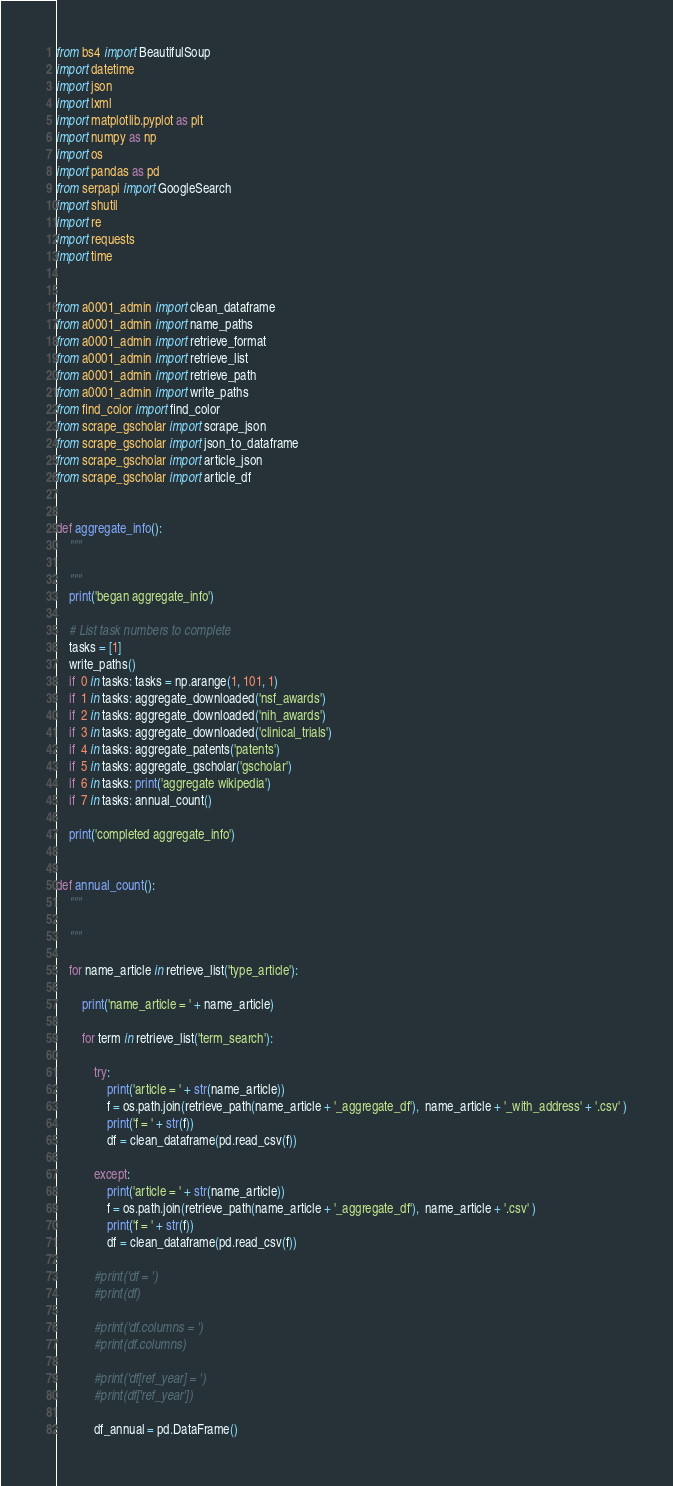Convert code to text. <code><loc_0><loc_0><loc_500><loc_500><_Python_>from bs4 import BeautifulSoup
import datetime
import json
import lxml
import matplotlib.pyplot as plt
import numpy as np
import os
import pandas as pd
from serpapi import GoogleSearch
import shutil
import re
import requests
import time


from a0001_admin import clean_dataframe
from a0001_admin import name_paths
from a0001_admin import retrieve_format
from a0001_admin import retrieve_list
from a0001_admin import retrieve_path
from a0001_admin import write_paths
from find_color import find_color
from scrape_gscholar import scrape_json
from scrape_gscholar import json_to_dataframe
from scrape_gscholar import article_json
from scrape_gscholar import article_df


def aggregate_info():
    """

    """
    print('began aggregate_info')

    # List task numbers to complete
    tasks = [1]
    write_paths()
    if  0 in tasks: tasks = np.arange(1, 101, 1)
    if  1 in tasks: aggregate_downloaded('nsf_awards')
    if  2 in tasks: aggregate_downloaded('nih_awards')
    if  3 in tasks: aggregate_downloaded('clinical_trials')
    if  4 in tasks: aggregate_patents('patents')
    if  5 in tasks: aggregate_gscholar('gscholar')
    if  6 in tasks: print('aggregate wikipedia')
    if  7 in tasks: annual_count()

    print('completed aggregate_info')


def annual_count():
    """

    """

    for name_article in retrieve_list('type_article'):

        print('name_article = ' + name_article)

        for term in retrieve_list('term_search'):

            try:
                print('article = ' + str(name_article))
                f = os.path.join(retrieve_path(name_article + '_aggregate_df'),  name_article + '_with_address' + '.csv' )
                print('f = ' + str(f))
                df = clean_dataframe(pd.read_csv(f))

            except:
                print('article = ' + str(name_article))
                f = os.path.join(retrieve_path(name_article + '_aggregate_df'),  name_article + '.csv' )
                print('f = ' + str(f))
                df = clean_dataframe(pd.read_csv(f))

            #print('df = ')
            #print(df)

            #print('df.columns = ')
            #print(df.columns)

            #print('df[ref_year] = ')
            #print(df['ref_year'])

            df_annual = pd.DataFrame()</code> 